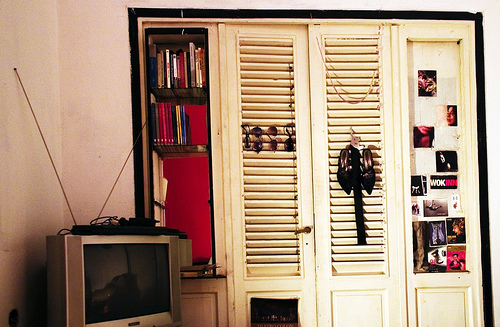Identify and read out the text in this image. WOKINN 